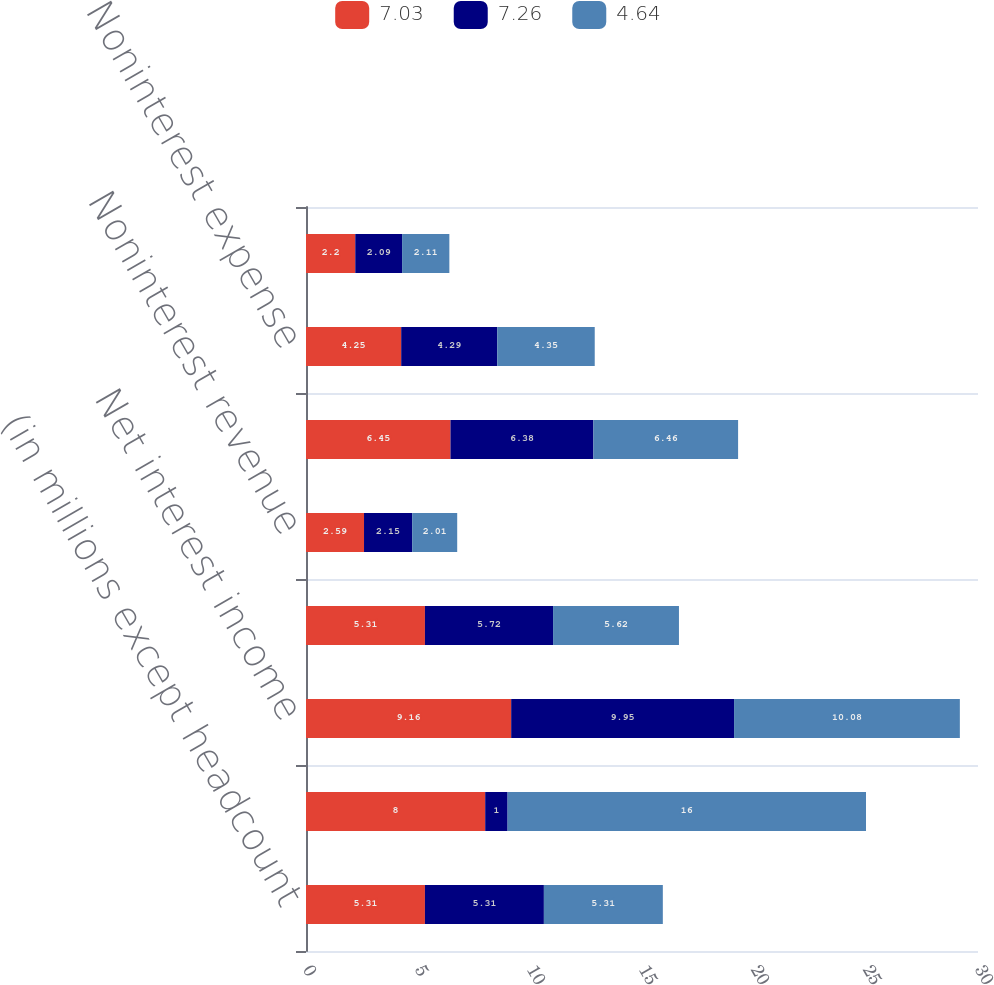<chart> <loc_0><loc_0><loc_500><loc_500><stacked_bar_chart><ecel><fcel>(in millions except headcount<fcel>Memo Net securitization gains<fcel>Net interest income<fcel>Provision for credit losses<fcel>Noninterest revenue<fcel>Risk adjusted margin (b)<fcel>Noninterest expense<fcel>Pre-tax income<nl><fcel>7.03<fcel>5.31<fcel>8<fcel>9.16<fcel>5.31<fcel>2.59<fcel>6.45<fcel>4.25<fcel>2.2<nl><fcel>7.26<fcel>5.31<fcel>1<fcel>9.95<fcel>5.72<fcel>2.15<fcel>6.38<fcel>4.29<fcel>2.09<nl><fcel>4.64<fcel>5.31<fcel>16<fcel>10.08<fcel>5.62<fcel>2.01<fcel>6.46<fcel>4.35<fcel>2.11<nl></chart> 